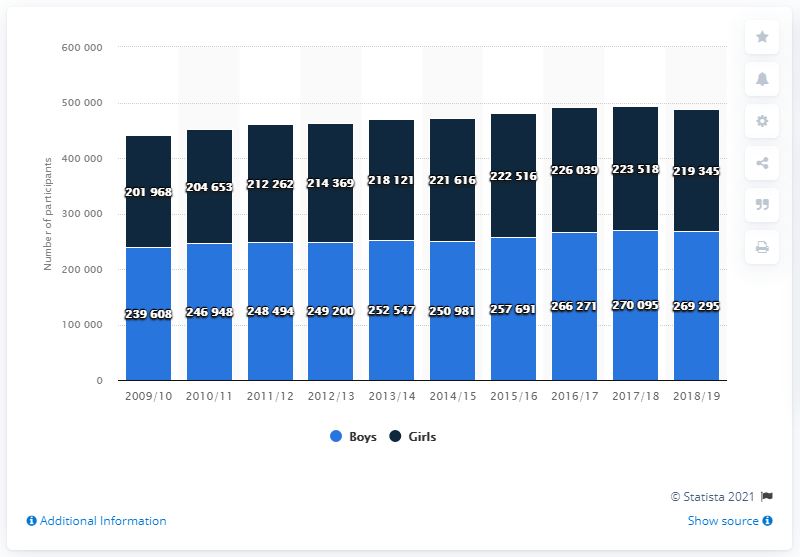Specify some key components in this picture. In the 2018/19 season, a total of 269,295 boys participated in cross country. 